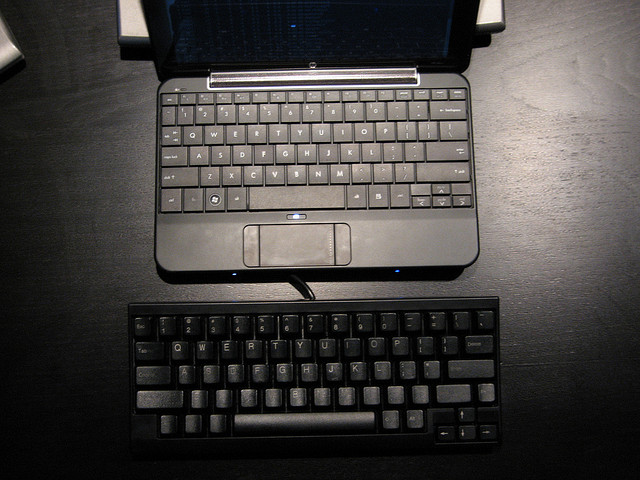Is it common for people to use an additional external keyboard with a laptop? Yes, it is quite common. The comfort and layout of external keyboards make them a popular choice for those who type extensively. Ergonomic considerations are especially important for people who use their laptops as their main workstations, as the fixed screen and keyboard positions on a laptop can cause discomfort over long periods of usage. An external keyboard allows users to create a more optimal and comfortable workstation setup.  What might be the downside of using an additional keyboard with a laptop? While there are many advantages to using an external keyboard with a laptop, there are some potential downsides. These include the extra space required for another keyboard, the additional weight and bulk when traveling, and the need for an extra peripheral which could mean more cables and potentially less desk space. Users must weigh these considerations against the ergonomic and functional benefits. 